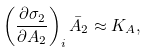Convert formula to latex. <formula><loc_0><loc_0><loc_500><loc_500>\left ( \frac { \partial \sigma _ { 2 } } { \partial A _ { 2 } } \right ) _ { i } \bar { A } _ { 2 } \approx K _ { A } ,</formula> 